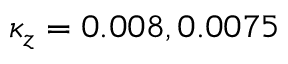Convert formula to latex. <formula><loc_0><loc_0><loc_500><loc_500>\kappa _ { z } = 0 . 0 0 8 , 0 . 0 0 7 5</formula> 